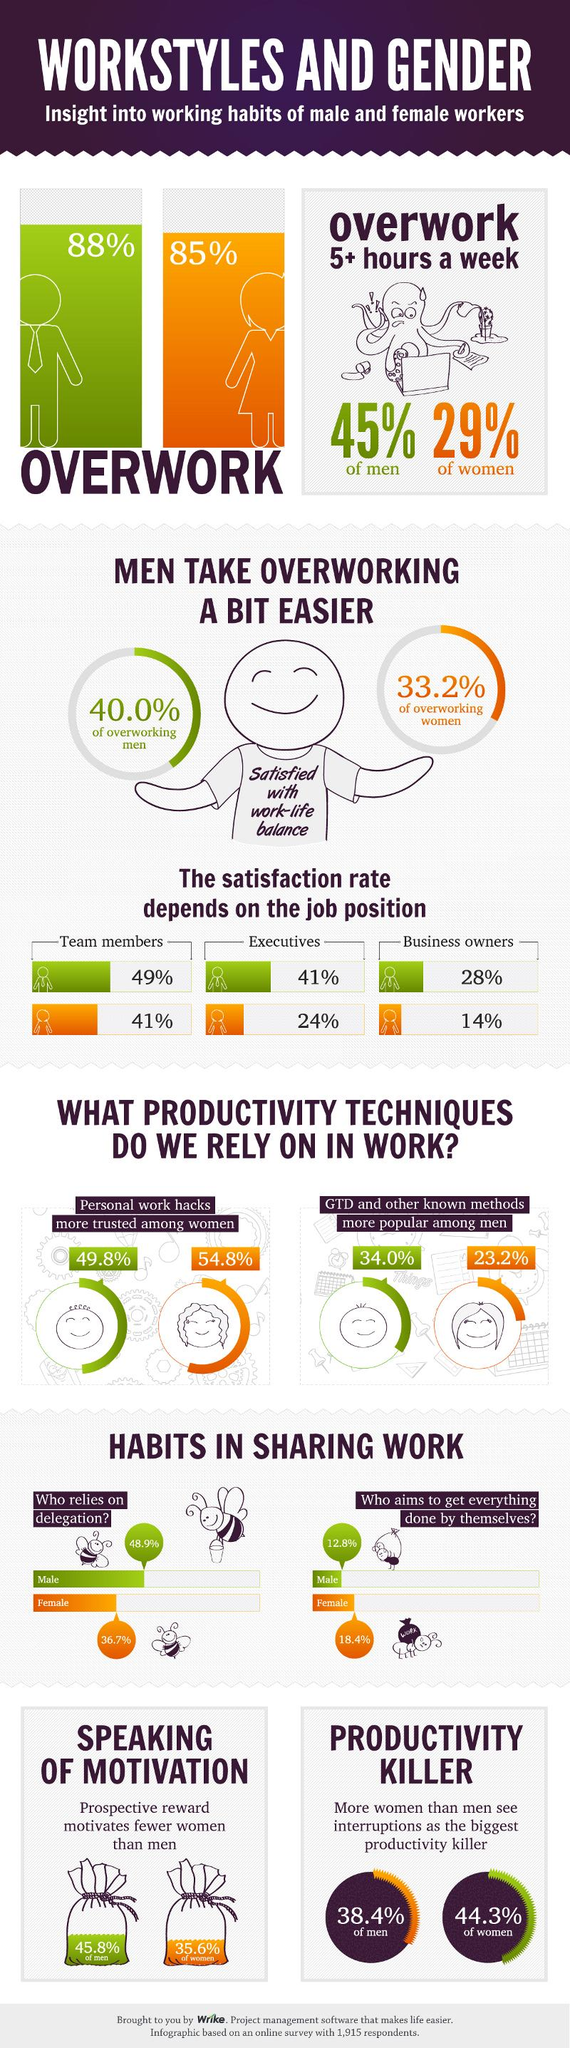Identify some key points in this picture. According to the survey, 35.6% of women were motivated by prospective rewards at work. According to a recent survey, the job satisfaction rate among female business owners is just 14%. According to the survey, 36.7% of the women employees in the workplace rely on delegation in their work. According to a recent survey, an overwhelming 88% of men are currently working more than they need to, indicating a widespread issue with work-life balance. According to the information provided, approximately 41% of female team members are satisfied with their current job. 